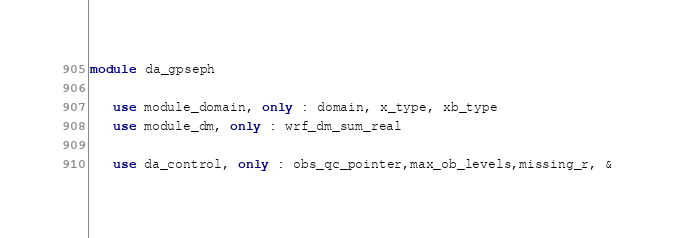<code> <loc_0><loc_0><loc_500><loc_500><_FORTRAN_>module da_gpseph

   use module_domain, only : domain, x_type, xb_type
   use module_dm, only : wrf_dm_sum_real

   use da_control, only : obs_qc_pointer,max_ob_levels,missing_r, &</code> 